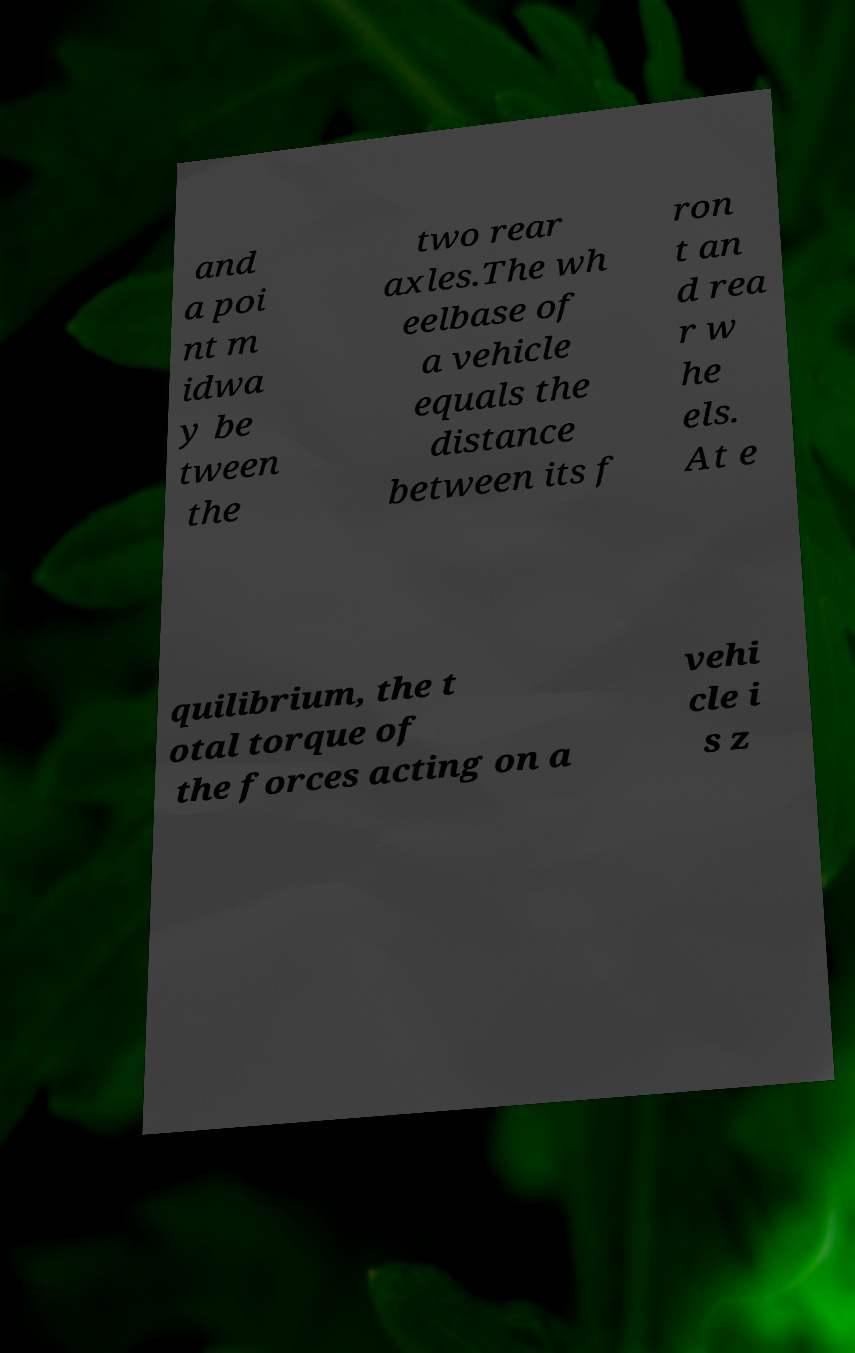What messages or text are displayed in this image? I need them in a readable, typed format. and a poi nt m idwa y be tween the two rear axles.The wh eelbase of a vehicle equals the distance between its f ron t an d rea r w he els. At e quilibrium, the t otal torque of the forces acting on a vehi cle i s z 